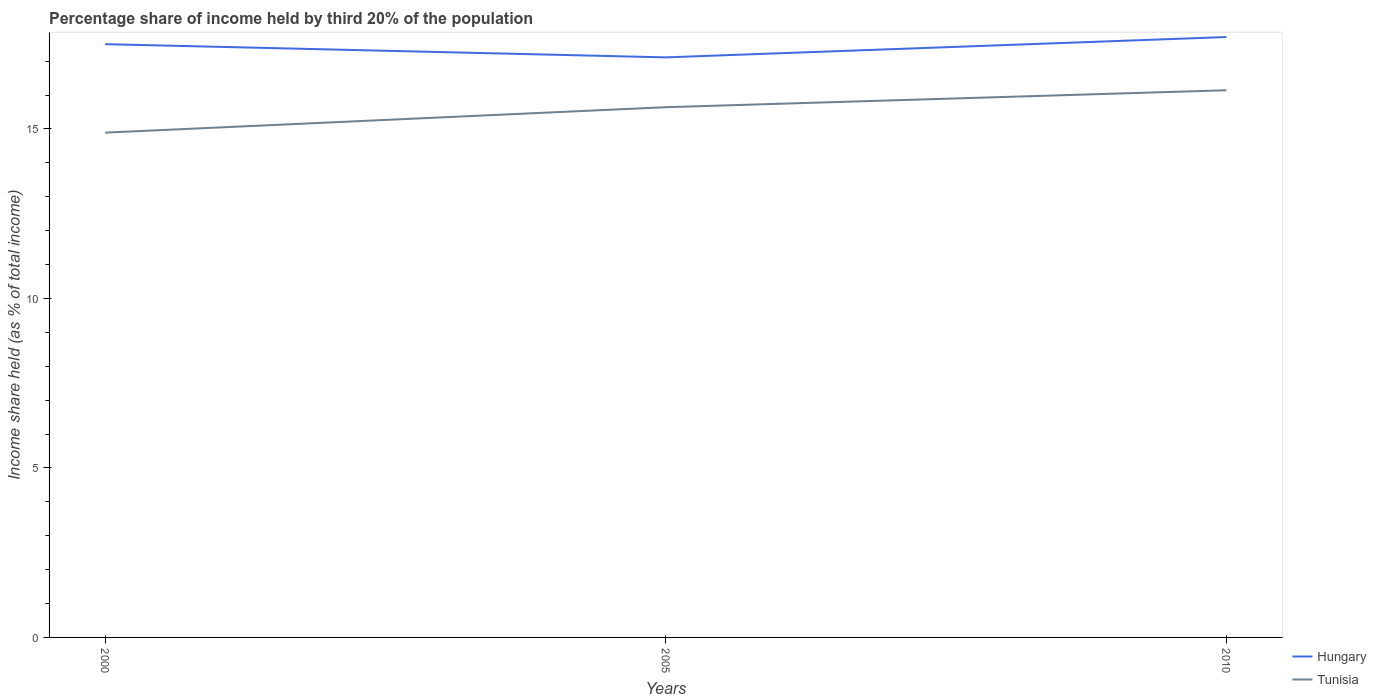How many different coloured lines are there?
Your answer should be very brief. 2. Across all years, what is the maximum share of income held by third 20% of the population in Tunisia?
Keep it short and to the point. 14.89. What is the total share of income held by third 20% of the population in Hungary in the graph?
Your answer should be very brief. -0.6. What is the difference between the highest and the second highest share of income held by third 20% of the population in Hungary?
Offer a terse response. 0.6. How many years are there in the graph?
Provide a short and direct response. 3. Does the graph contain grids?
Provide a short and direct response. No. What is the title of the graph?
Give a very brief answer. Percentage share of income held by third 20% of the population. What is the label or title of the X-axis?
Offer a very short reply. Years. What is the label or title of the Y-axis?
Provide a short and direct response. Income share held (as % of total income). What is the Income share held (as % of total income) in Tunisia in 2000?
Keep it short and to the point. 14.89. What is the Income share held (as % of total income) in Hungary in 2005?
Provide a succinct answer. 17.11. What is the Income share held (as % of total income) of Tunisia in 2005?
Your response must be concise. 15.64. What is the Income share held (as % of total income) in Hungary in 2010?
Provide a short and direct response. 17.71. What is the Income share held (as % of total income) of Tunisia in 2010?
Keep it short and to the point. 16.14. Across all years, what is the maximum Income share held (as % of total income) of Hungary?
Give a very brief answer. 17.71. Across all years, what is the maximum Income share held (as % of total income) in Tunisia?
Offer a terse response. 16.14. Across all years, what is the minimum Income share held (as % of total income) in Hungary?
Ensure brevity in your answer.  17.11. Across all years, what is the minimum Income share held (as % of total income) of Tunisia?
Give a very brief answer. 14.89. What is the total Income share held (as % of total income) in Hungary in the graph?
Ensure brevity in your answer.  52.32. What is the total Income share held (as % of total income) in Tunisia in the graph?
Provide a succinct answer. 46.67. What is the difference between the Income share held (as % of total income) of Hungary in 2000 and that in 2005?
Provide a short and direct response. 0.39. What is the difference between the Income share held (as % of total income) of Tunisia in 2000 and that in 2005?
Offer a terse response. -0.75. What is the difference between the Income share held (as % of total income) of Hungary in 2000 and that in 2010?
Your response must be concise. -0.21. What is the difference between the Income share held (as % of total income) of Tunisia in 2000 and that in 2010?
Offer a terse response. -1.25. What is the difference between the Income share held (as % of total income) of Hungary in 2005 and that in 2010?
Offer a very short reply. -0.6. What is the difference between the Income share held (as % of total income) of Tunisia in 2005 and that in 2010?
Provide a succinct answer. -0.5. What is the difference between the Income share held (as % of total income) of Hungary in 2000 and the Income share held (as % of total income) of Tunisia in 2005?
Ensure brevity in your answer.  1.86. What is the difference between the Income share held (as % of total income) of Hungary in 2000 and the Income share held (as % of total income) of Tunisia in 2010?
Your answer should be compact. 1.36. What is the average Income share held (as % of total income) in Hungary per year?
Keep it short and to the point. 17.44. What is the average Income share held (as % of total income) of Tunisia per year?
Give a very brief answer. 15.56. In the year 2000, what is the difference between the Income share held (as % of total income) in Hungary and Income share held (as % of total income) in Tunisia?
Your answer should be very brief. 2.61. In the year 2005, what is the difference between the Income share held (as % of total income) in Hungary and Income share held (as % of total income) in Tunisia?
Give a very brief answer. 1.47. In the year 2010, what is the difference between the Income share held (as % of total income) in Hungary and Income share held (as % of total income) in Tunisia?
Keep it short and to the point. 1.57. What is the ratio of the Income share held (as % of total income) of Hungary in 2000 to that in 2005?
Offer a terse response. 1.02. What is the ratio of the Income share held (as % of total income) of Tunisia in 2000 to that in 2005?
Keep it short and to the point. 0.95. What is the ratio of the Income share held (as % of total income) in Tunisia in 2000 to that in 2010?
Provide a short and direct response. 0.92. What is the ratio of the Income share held (as % of total income) of Hungary in 2005 to that in 2010?
Your answer should be very brief. 0.97. What is the difference between the highest and the second highest Income share held (as % of total income) in Hungary?
Provide a succinct answer. 0.21. What is the difference between the highest and the lowest Income share held (as % of total income) of Hungary?
Give a very brief answer. 0.6. What is the difference between the highest and the lowest Income share held (as % of total income) of Tunisia?
Offer a terse response. 1.25. 